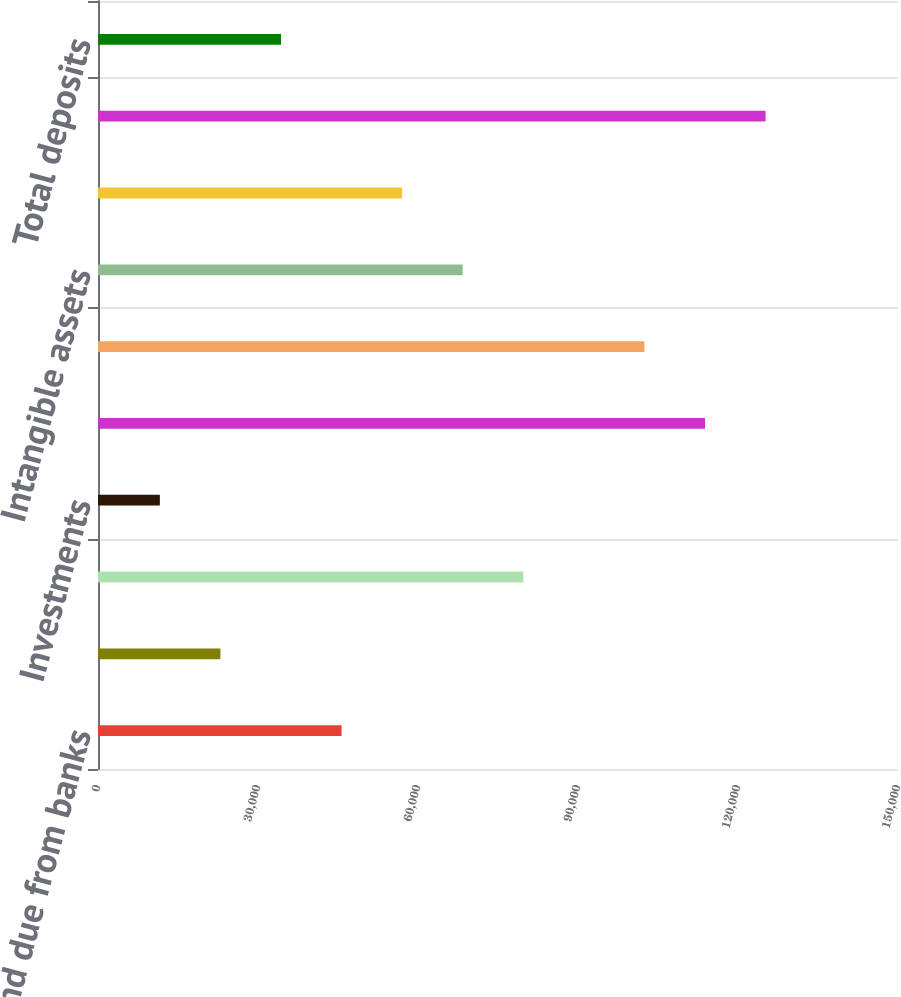<chart> <loc_0><loc_0><loc_500><loc_500><bar_chart><fcel>Cash and due from banks<fcel>Deposits with banks<fcel>Trading account assets<fcel>Investments<fcel>Loans net of unearned income<fcel>Total loans net<fcel>Intangible assets<fcel>Other assets<fcel>Total assets<fcel>Total deposits<nl><fcel>45670.4<fcel>22956.2<fcel>79741.7<fcel>11599.1<fcel>113813<fcel>102456<fcel>68384.6<fcel>57027.5<fcel>125170<fcel>34313.3<nl></chart> 